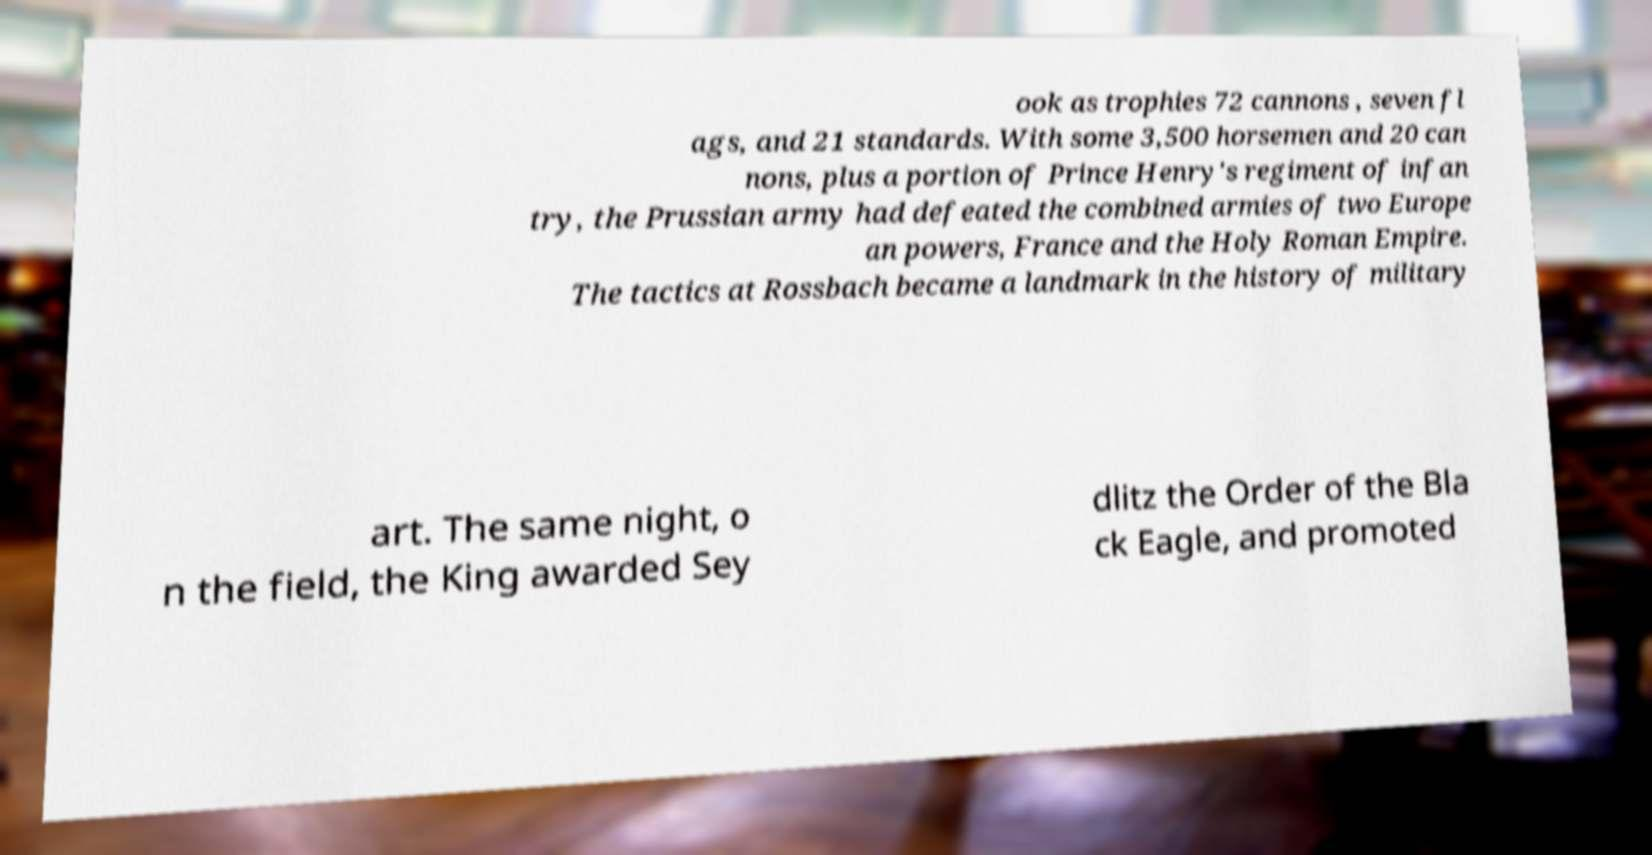Please read and relay the text visible in this image. What does it say? ook as trophies 72 cannons , seven fl ags, and 21 standards. With some 3,500 horsemen and 20 can nons, plus a portion of Prince Henry's regiment of infan try, the Prussian army had defeated the combined armies of two Europe an powers, France and the Holy Roman Empire. The tactics at Rossbach became a landmark in the history of military art. The same night, o n the field, the King awarded Sey dlitz the Order of the Bla ck Eagle, and promoted 